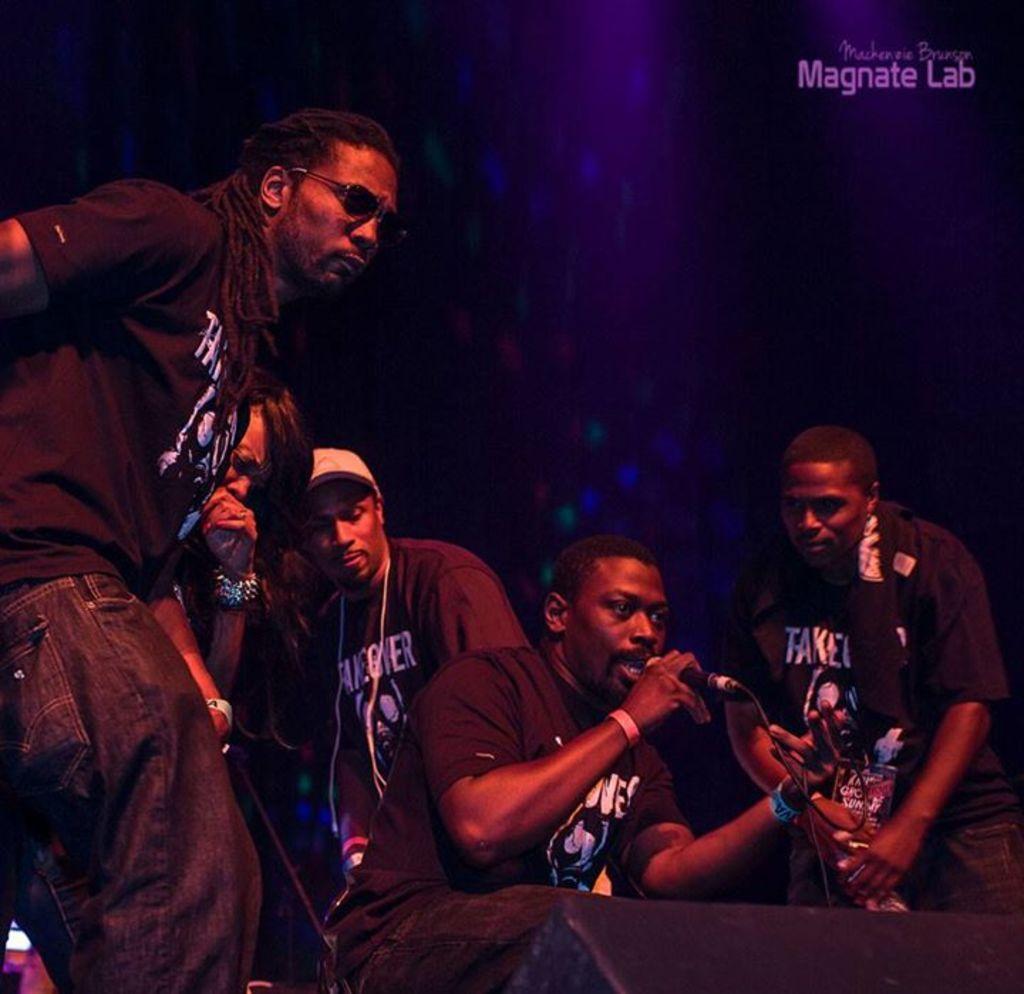In one or two sentences, can you explain what this image depicts? In this picture there are several musicians singing with mics in front of them. In the background there is a designed wall on top of which Magnate lab is written. 